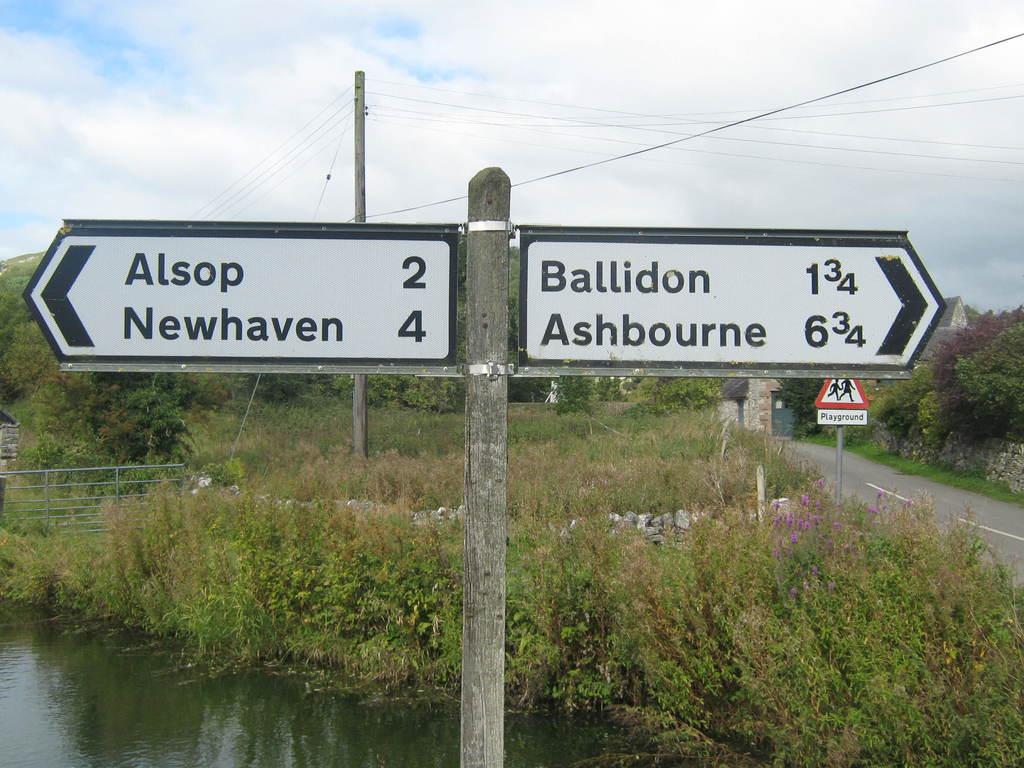How far is it to newhaven?
Give a very brief answer. 4. How far is it to alsop?
Keep it short and to the point. 2. 